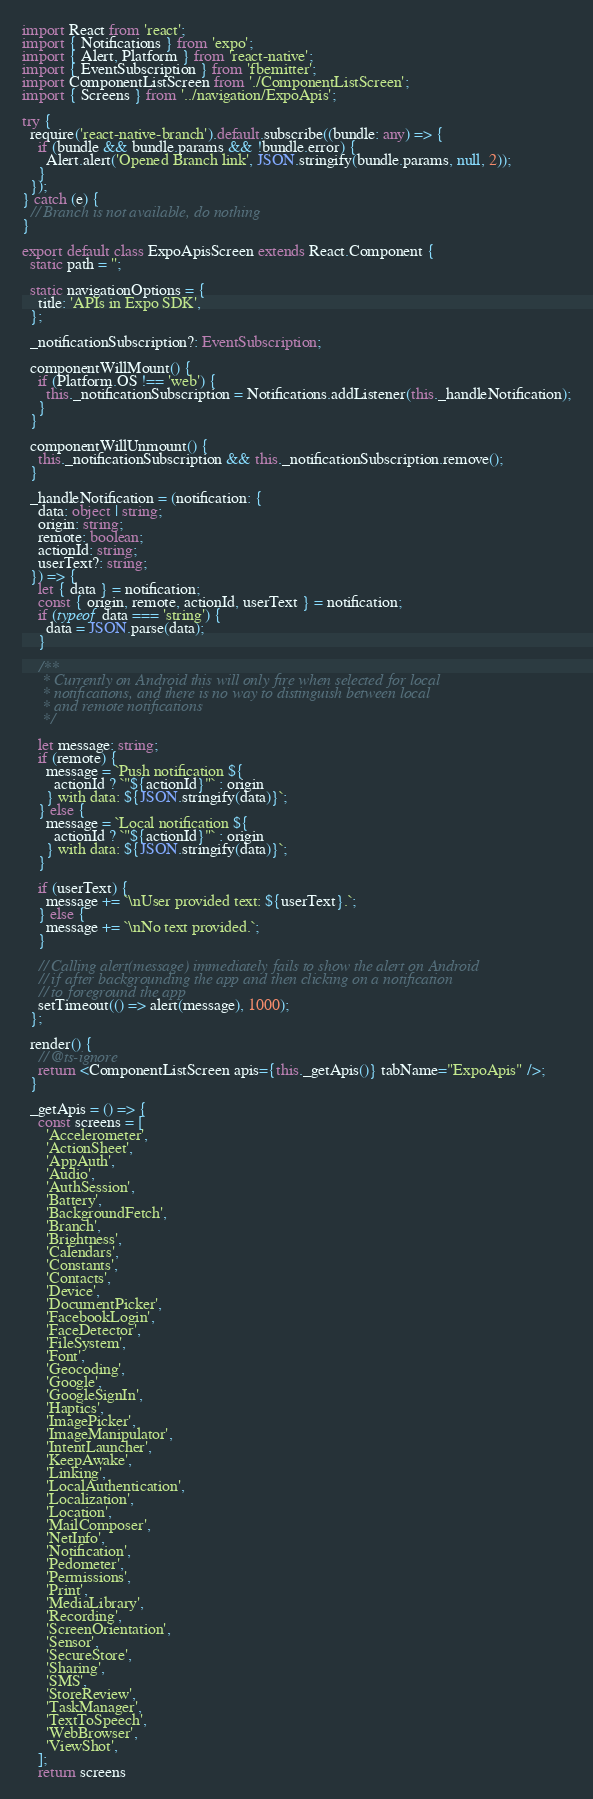Convert code to text. <code><loc_0><loc_0><loc_500><loc_500><_TypeScript_>import React from 'react';
import { Notifications } from 'expo';
import { Alert, Platform } from 'react-native';
import { EventSubscription } from 'fbemitter';
import ComponentListScreen from './ComponentListScreen';
import { Screens } from '../navigation/ExpoApis';

try {
  require('react-native-branch').default.subscribe((bundle: any) => {
    if (bundle && bundle.params && !bundle.error) {
      Alert.alert('Opened Branch link', JSON.stringify(bundle.params, null, 2));
    }
  });
} catch (e) {
  // Branch is not available, do nothing
}

export default class ExpoApisScreen extends React.Component {
  static path = '';

  static navigationOptions = {
    title: 'APIs in Expo SDK',
  };

  _notificationSubscription?: EventSubscription;

  componentWillMount() {
    if (Platform.OS !== 'web') {
      this._notificationSubscription = Notifications.addListener(this._handleNotification);
    }
  }

  componentWillUnmount() {
    this._notificationSubscription && this._notificationSubscription.remove();
  }

  _handleNotification = (notification: {
    data: object | string;
    origin: string;
    remote: boolean;
    actionId: string;
    userText?: string;
  }) => {
    let { data } = notification;
    const { origin, remote, actionId, userText } = notification;
    if (typeof data === 'string') {
      data = JSON.parse(data);
    }

    /**
     * Currently on Android this will only fire when selected for local
     * notifications, and there is no way to distinguish between local
     * and remote notifications
     */

    let message: string;
    if (remote) {
      message = `Push notification ${
        actionId ? `"${actionId}"` : origin
      } with data: ${JSON.stringify(data)}`;
    } else {
      message = `Local notification ${
        actionId ? `"${actionId}"` : origin
      } with data: ${JSON.stringify(data)}`;
    }

    if (userText) {
      message += `\nUser provided text: ${userText}.`;
    } else {
      message += `\nNo text provided.`;
    }

    // Calling alert(message) immediately fails to show the alert on Android
    // if after backgrounding the app and then clicking on a notification
    // to foreground the app
    setTimeout(() => alert(message), 1000);
  };

  render() {
    // @ts-ignore
    return <ComponentListScreen apis={this._getApis()} tabName="ExpoApis" />;
  }

  _getApis = () => {
    const screens = [
      'Accelerometer',
      'ActionSheet',
      'AppAuth',
      'Audio',
      'AuthSession',
      'Battery',
      'BackgroundFetch',
      'Branch',
      'Brightness',
      'Calendars',
      'Constants',
      'Contacts',
      'Device',
      'DocumentPicker',
      'FacebookLogin',
      'FaceDetector',
      'FileSystem',
      'Font',
      'Geocoding',
      'Google',
      'GoogleSignIn',
      'Haptics',
      'ImagePicker',
      'ImageManipulator',
      'IntentLauncher',
      'KeepAwake',
      'Linking',
      'LocalAuthentication',
      'Localization',
      'Location',
      'MailComposer',
      'NetInfo',
      'Notification',
      'Pedometer',
      'Permissions',
      'Print',
      'MediaLibrary',
      'Recording',
      'ScreenOrientation',
      'Sensor',
      'SecureStore',
      'Sharing',
      'SMS',
      'StoreReview',
      'TaskManager',
      'TextToSpeech',
      'WebBrowser',
      'ViewShot',
    ];
    return screens</code> 